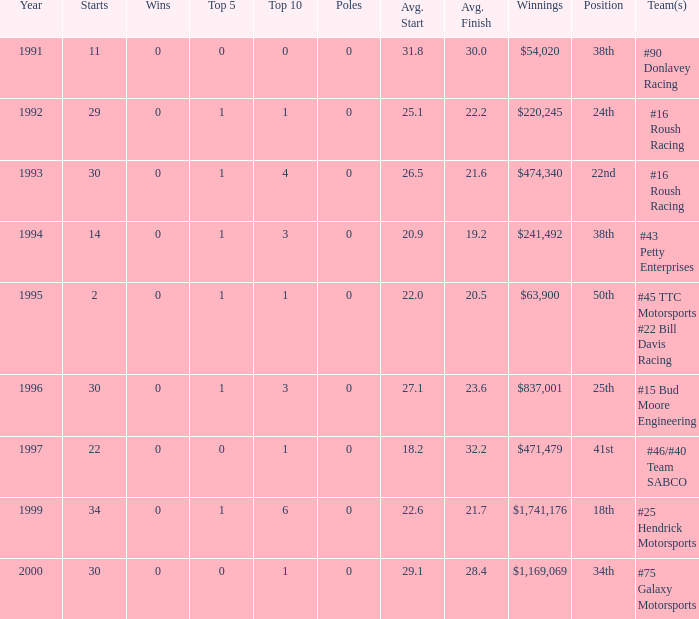At which position in the top 10 did the winnings of $1,741,176 stand? 6.0. 